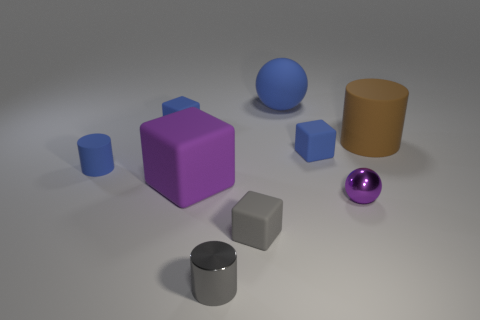Subtract 1 blocks. How many blocks are left? 3 Add 1 large brown cylinders. How many objects exist? 10 Subtract all spheres. How many objects are left? 7 Add 7 blue rubber cylinders. How many blue rubber cylinders are left? 8 Add 8 blue cylinders. How many blue cylinders exist? 9 Subtract 0 cyan cylinders. How many objects are left? 9 Subtract all balls. Subtract all tiny purple objects. How many objects are left? 6 